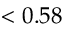Convert formula to latex. <formula><loc_0><loc_0><loc_500><loc_500>< 0 . 5 8</formula> 